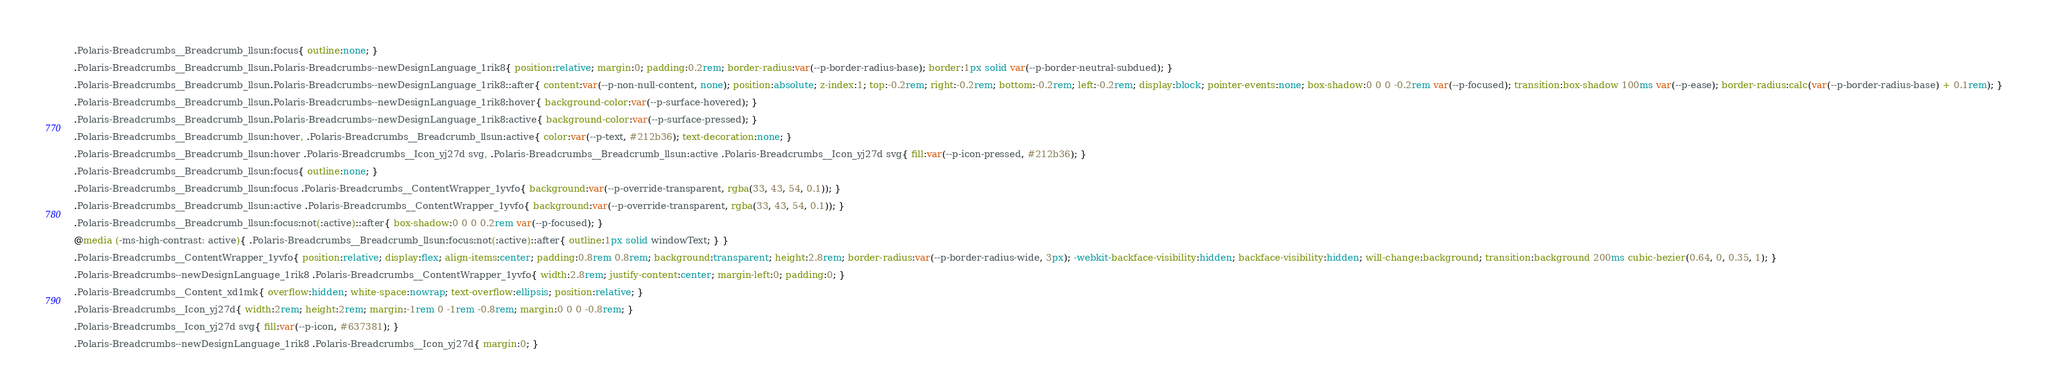<code> <loc_0><loc_0><loc_500><loc_500><_CSS_>.Polaris-Breadcrumbs__Breadcrumb_llsun:focus{ outline:none; }

.Polaris-Breadcrumbs__Breadcrumb_llsun.Polaris-Breadcrumbs--newDesignLanguage_1rik8{ position:relative; margin:0; padding:0.2rem; border-radius:var(--p-border-radius-base); border:1px solid var(--p-border-neutral-subdued); }

.Polaris-Breadcrumbs__Breadcrumb_llsun.Polaris-Breadcrumbs--newDesignLanguage_1rik8::after{ content:var(--p-non-null-content, none); position:absolute; z-index:1; top:-0.2rem; right:-0.2rem; bottom:-0.2rem; left:-0.2rem; display:block; pointer-events:none; box-shadow:0 0 0 -0.2rem var(--p-focused); transition:box-shadow 100ms var(--p-ease); border-radius:calc(var(--p-border-radius-base) + 0.1rem); }

.Polaris-Breadcrumbs__Breadcrumb_llsun.Polaris-Breadcrumbs--newDesignLanguage_1rik8:hover{ background-color:var(--p-surface-hovered); }

.Polaris-Breadcrumbs__Breadcrumb_llsun.Polaris-Breadcrumbs--newDesignLanguage_1rik8:active{ background-color:var(--p-surface-pressed); }

.Polaris-Breadcrumbs__Breadcrumb_llsun:hover, .Polaris-Breadcrumbs__Breadcrumb_llsun:active{ color:var(--p-text, #212b36); text-decoration:none; }

.Polaris-Breadcrumbs__Breadcrumb_llsun:hover .Polaris-Breadcrumbs__Icon_yj27d svg, .Polaris-Breadcrumbs__Breadcrumb_llsun:active .Polaris-Breadcrumbs__Icon_yj27d svg{ fill:var(--p-icon-pressed, #212b36); }

.Polaris-Breadcrumbs__Breadcrumb_llsun:focus{ outline:none; }

.Polaris-Breadcrumbs__Breadcrumb_llsun:focus .Polaris-Breadcrumbs__ContentWrapper_1yvfo{ background:var(--p-override-transparent, rgba(33, 43, 54, 0.1)); }

.Polaris-Breadcrumbs__Breadcrumb_llsun:active .Polaris-Breadcrumbs__ContentWrapper_1yvfo{ background:var(--p-override-transparent, rgba(33, 43, 54, 0.1)); }

.Polaris-Breadcrumbs__Breadcrumb_llsun:focus:not(:active)::after{ box-shadow:0 0 0 0.2rem var(--p-focused); }

@media (-ms-high-contrast: active){ .Polaris-Breadcrumbs__Breadcrumb_llsun:focus:not(:active)::after{ outline:1px solid windowText; } }

.Polaris-Breadcrumbs__ContentWrapper_1yvfo{ position:relative; display:flex; align-items:center; padding:0.8rem 0.8rem; background:transparent; height:2.8rem; border-radius:var(--p-border-radius-wide, 3px); -webkit-backface-visibility:hidden; backface-visibility:hidden; will-change:background; transition:background 200ms cubic-bezier(0.64, 0, 0.35, 1); }

.Polaris-Breadcrumbs--newDesignLanguage_1rik8 .Polaris-Breadcrumbs__ContentWrapper_1yvfo{ width:2.8rem; justify-content:center; margin-left:0; padding:0; }

.Polaris-Breadcrumbs__Content_xd1mk{ overflow:hidden; white-space:nowrap; text-overflow:ellipsis; position:relative; }

.Polaris-Breadcrumbs__Icon_yj27d{ width:2rem; height:2rem; margin:-1rem 0 -1rem -0.8rem; margin:0 0 0 -0.8rem; }

.Polaris-Breadcrumbs__Icon_yj27d svg{ fill:var(--p-icon, #637381); }

.Polaris-Breadcrumbs--newDesignLanguage_1rik8 .Polaris-Breadcrumbs__Icon_yj27d{ margin:0; }
</code> 